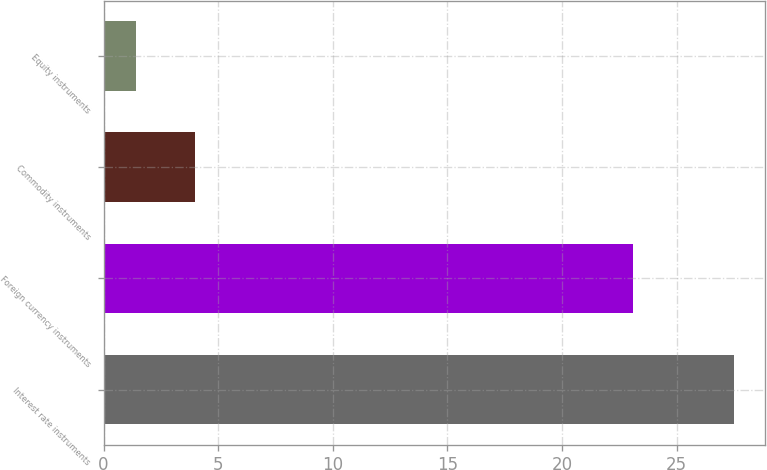<chart> <loc_0><loc_0><loc_500><loc_500><bar_chart><fcel>Interest rate instruments<fcel>Foreign currency instruments<fcel>Commodity instruments<fcel>Equity instruments<nl><fcel>27.5<fcel>23.1<fcel>4.01<fcel>1.4<nl></chart> 